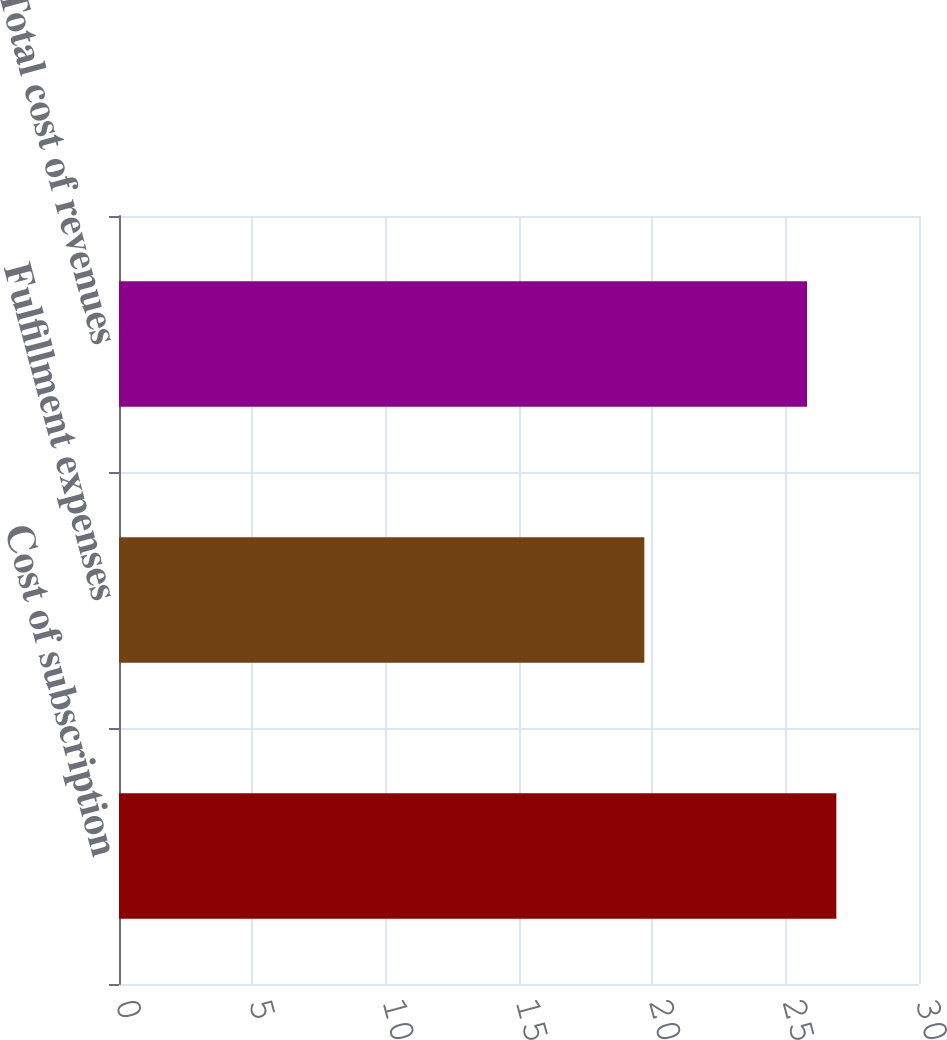<chart> <loc_0><loc_0><loc_500><loc_500><bar_chart><fcel>Cost of subscription<fcel>Fulfillment expenses<fcel>Total cost of revenues<nl><fcel>26.9<fcel>19.7<fcel>25.8<nl></chart> 